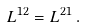Convert formula to latex. <formula><loc_0><loc_0><loc_500><loc_500>L ^ { 1 2 } = L ^ { 2 1 } \, .</formula> 